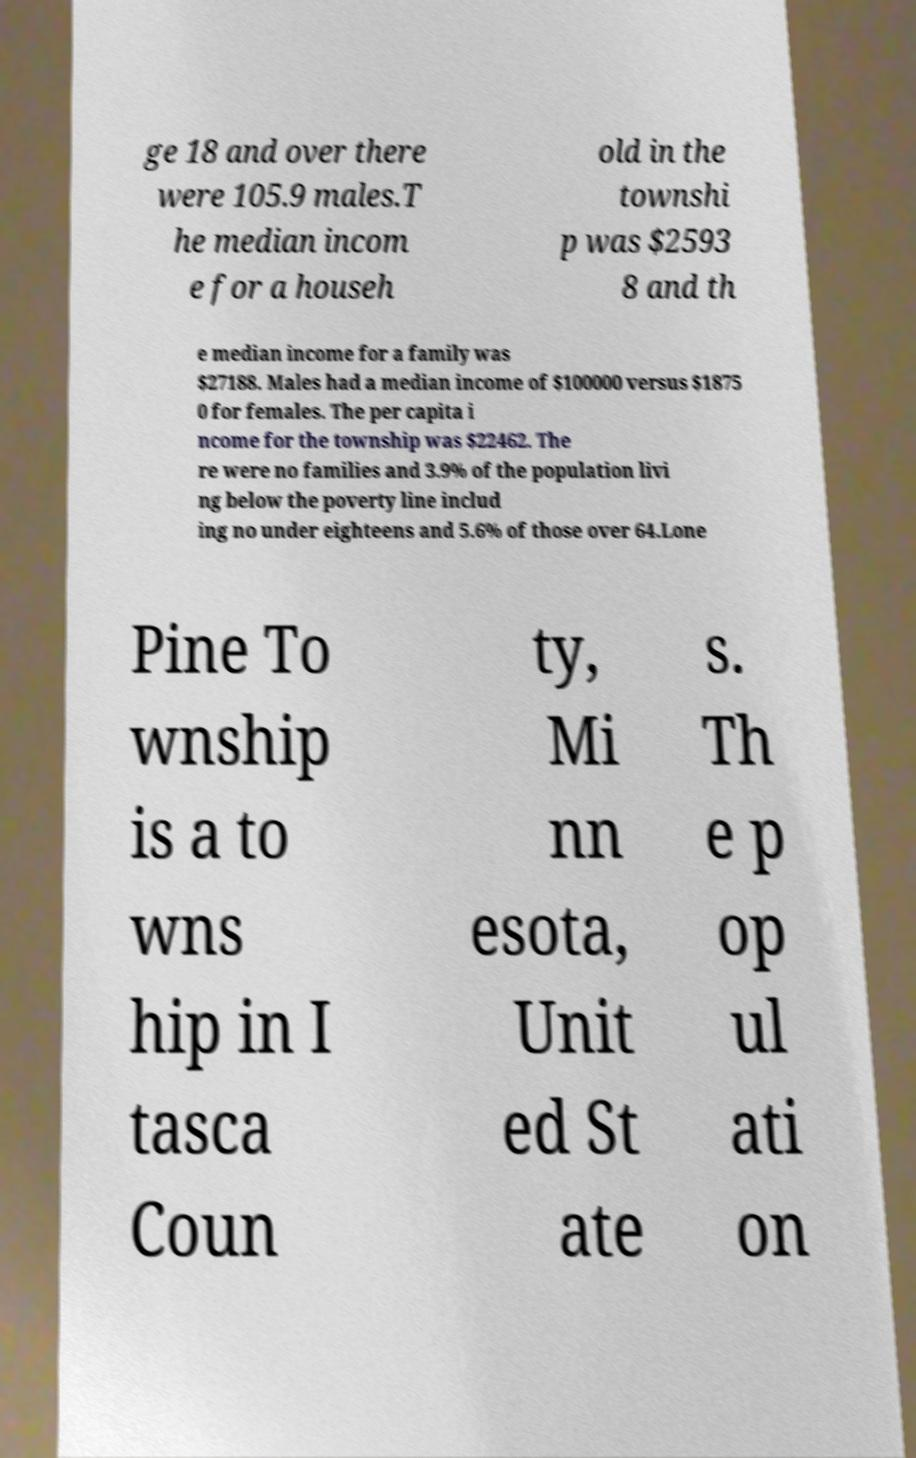Could you extract and type out the text from this image? ge 18 and over there were 105.9 males.T he median incom e for a househ old in the townshi p was $2593 8 and th e median income for a family was $27188. Males had a median income of $100000 versus $1875 0 for females. The per capita i ncome for the township was $22462. The re were no families and 3.9% of the population livi ng below the poverty line includ ing no under eighteens and 5.6% of those over 64.Lone Pine To wnship is a to wns hip in I tasca Coun ty, Mi nn esota, Unit ed St ate s. Th e p op ul ati on 